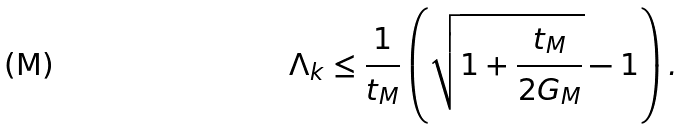Convert formula to latex. <formula><loc_0><loc_0><loc_500><loc_500>\Lambda _ { k } \leq \frac { 1 } { t _ { M } } \left ( \sqrt { 1 + \frac { t _ { M } } { 2 G _ { M } } } - 1 \right ) .</formula> 